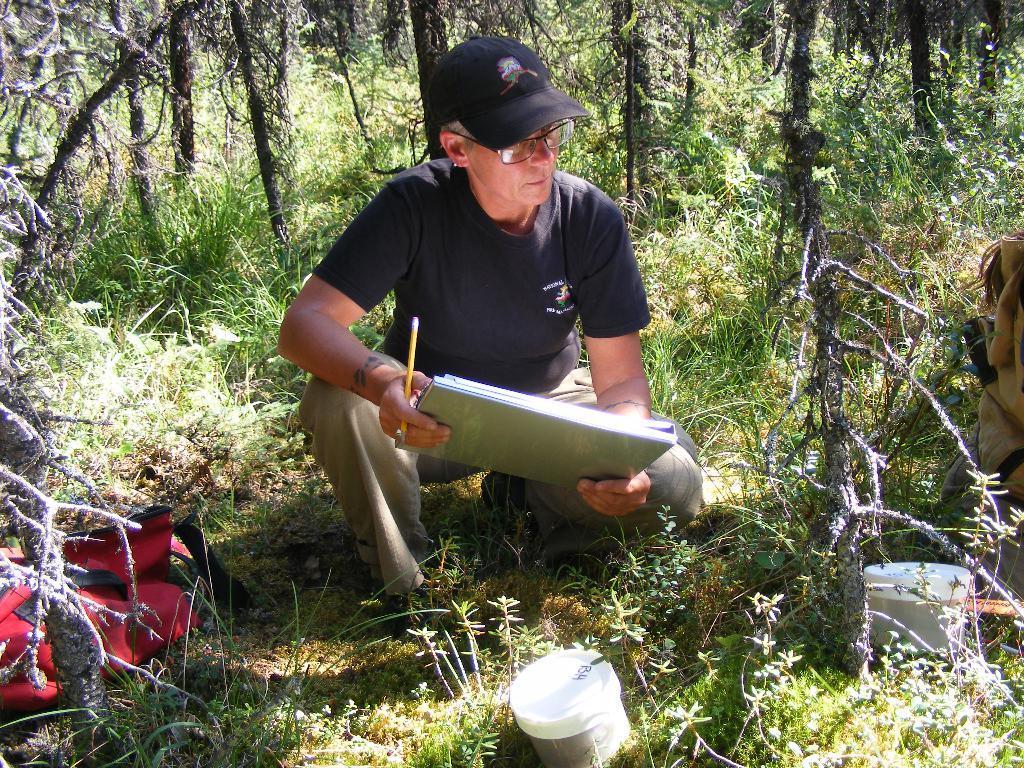Please provide a concise description of this image. In the middle of the image we can see a man sitting on the grass and holding stationary in his hands. In the background we can see trees, plants, grass, bag and storage boxes. 